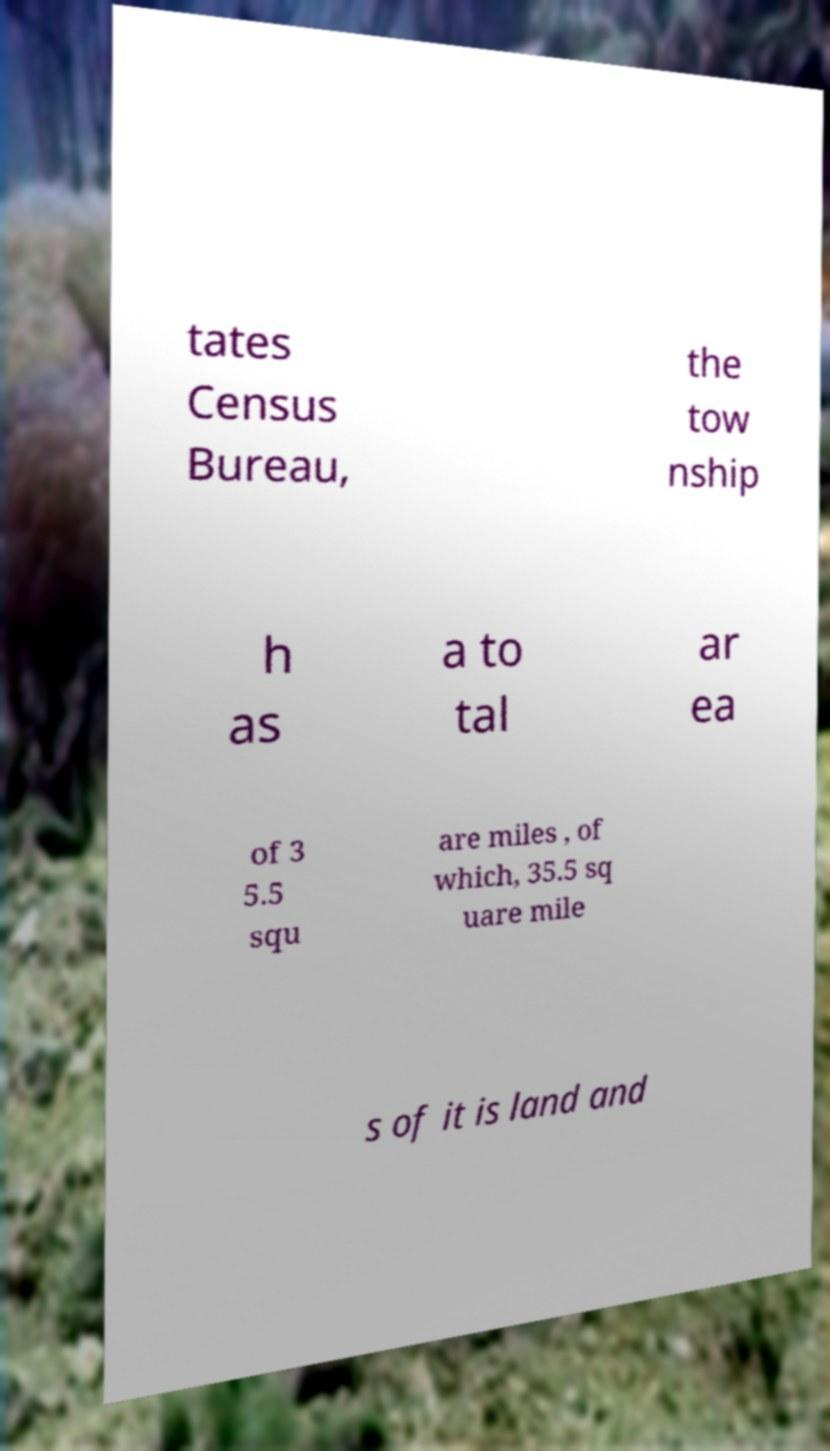Could you assist in decoding the text presented in this image and type it out clearly? tates Census Bureau, the tow nship h as a to tal ar ea of 3 5.5 squ are miles , of which, 35.5 sq uare mile s of it is land and 